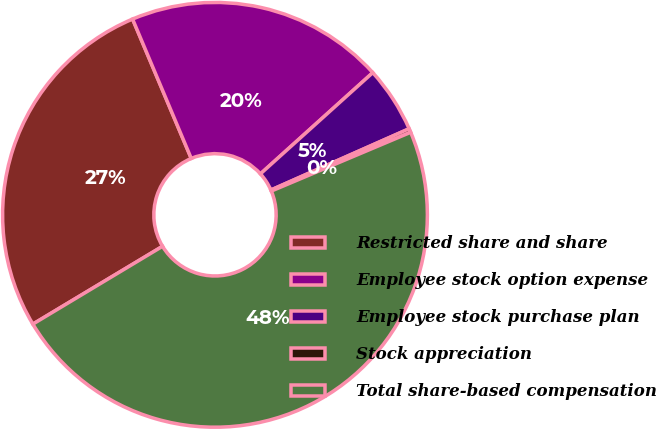<chart> <loc_0><loc_0><loc_500><loc_500><pie_chart><fcel>Restricted share and share<fcel>Employee stock option expense<fcel>Employee stock purchase plan<fcel>Stock appreciation<fcel>Total share-based compensation<nl><fcel>27.26%<fcel>19.67%<fcel>5.03%<fcel>0.29%<fcel>47.75%<nl></chart> 